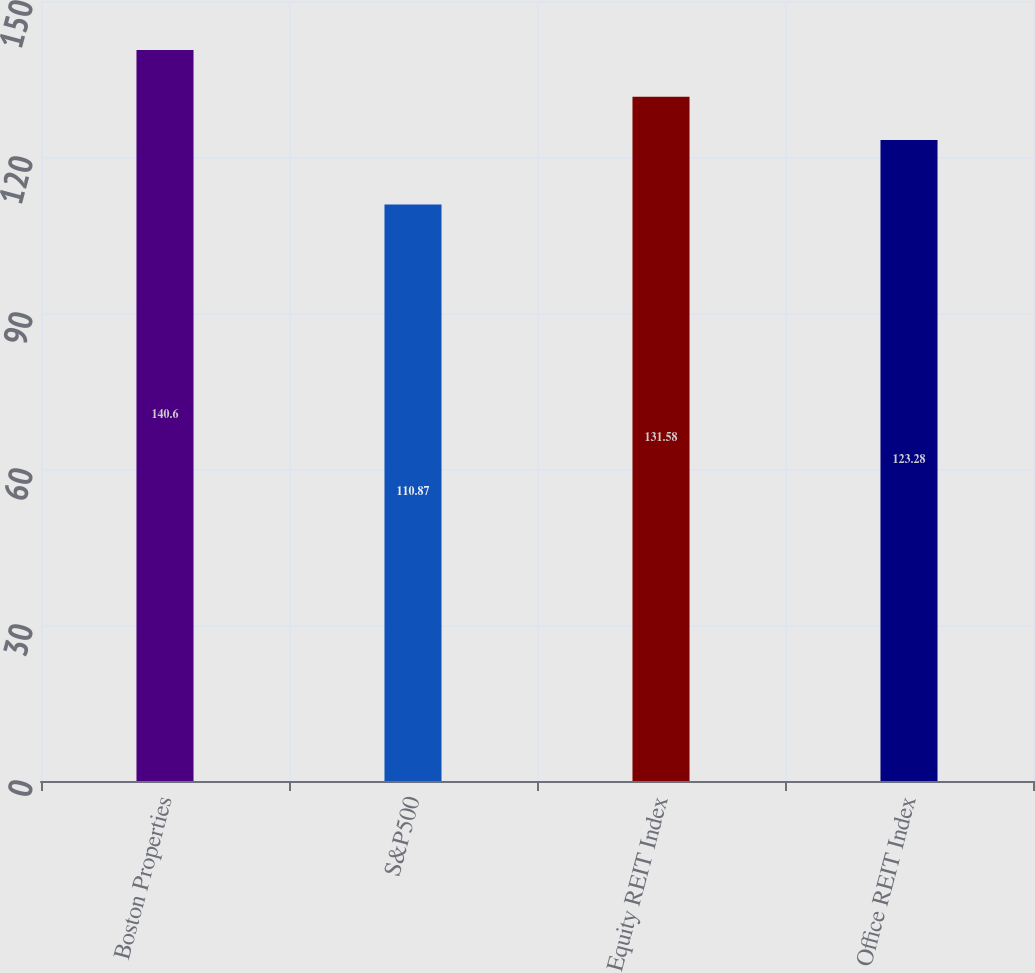Convert chart. <chart><loc_0><loc_0><loc_500><loc_500><bar_chart><fcel>Boston Properties<fcel>S&P500<fcel>Equity REIT Index<fcel>Office REIT Index<nl><fcel>140.6<fcel>110.87<fcel>131.58<fcel>123.28<nl></chart> 